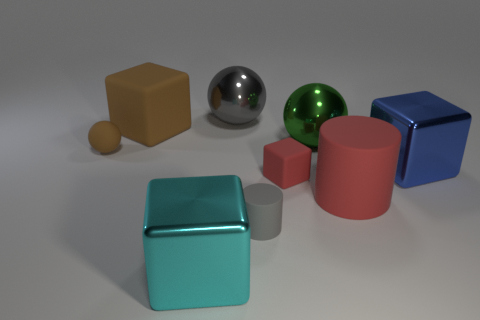The rubber block that is the same color as the large cylinder is what size?
Keep it short and to the point. Small. There is a tiny matte block; does it have the same color as the big rubber object that is right of the large gray sphere?
Your answer should be very brief. Yes. What number of things have the same color as the small ball?
Your answer should be compact. 1. What number of spheres are either red objects or small brown rubber things?
Offer a very short reply. 1. The large metallic cube that is on the left side of the small red rubber object is what color?
Your answer should be compact. Cyan. The red thing that is the same size as the gray cylinder is what shape?
Ensure brevity in your answer.  Cube. There is a gray metallic sphere; what number of small matte objects are to the left of it?
Offer a terse response. 1. What number of objects are big cylinders or tiny blue rubber balls?
Offer a very short reply. 1. There is a metal object that is both in front of the rubber sphere and on the left side of the large red rubber cylinder; what is its shape?
Your answer should be very brief. Cube. How many matte balls are there?
Provide a succinct answer. 1. 